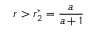Convert formula to latex. <formula><loc_0><loc_0><loc_500><loc_500>r > r _ { 2 } ^ { * } = \frac { a } { a + 1 }</formula> 